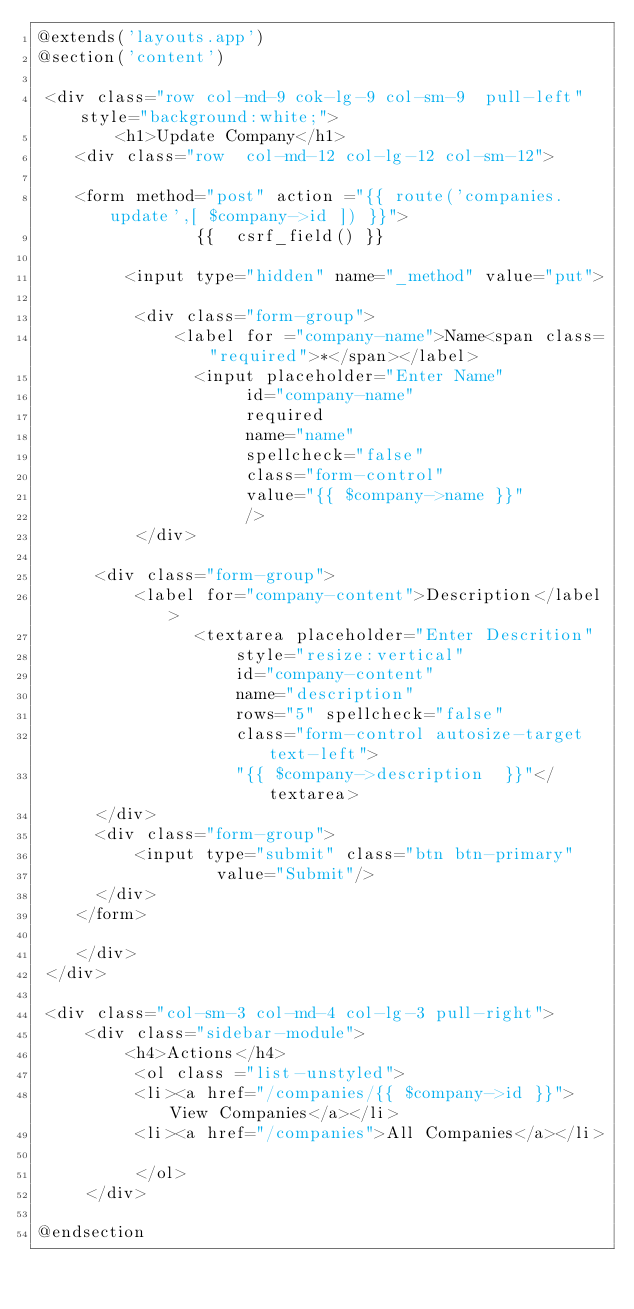Convert code to text. <code><loc_0><loc_0><loc_500><loc_500><_PHP_>@extends('layouts.app')
@section('content')

 <div class="row col-md-9 cok-lg-9 col-sm-9  pull-left" style="background:white;">
        <h1>Update Company</h1>
    <div class="row  col-md-12 col-lg-12 col-sm-12">

    <form method="post" action ="{{ route('companies.update',[ $company->id ]) }}">
                {{  csrf_field() }}

         <input type="hidden" name="_method" value="put">

          <div class="form-group">
              <label for ="company-name">Name<span class="required">*</span></label>
                <input placeholder="Enter Name"
                     id="company-name"
                     required
                     name="name"
                     spellcheck="false"
                     class="form-control"
                     value="{{ $company->name }}"
                     />
          </div>

      <div class="form-group">
          <label for="company-content">Description</label>
                <textarea placeholder="Enter Descrition"
                    style="resize:vertical"
                    id="company-content"
                    name="description"
                    rows="5" spellcheck="false"
                    class="form-control autosize-target text-left">
                    "{{ $company->description  }}"</textarea>
      </div>
      <div class="form-group">
          <input type="submit" class="btn btn-primary"
                  value="Submit"/>
      </div>
    </form>

    </div>
 </div>

 <div class="col-sm-3 col-md-4 col-lg-3 pull-right">
     <div class="sidebar-module">
         <h4>Actions</h4>
          <ol class ="list-unstyled">
          <li><a href="/companies/{{ $company->id }}">View Companies</a></li>
          <li><a href="/companies">All Companies</a></li>

          </ol>
     </div>

@endsection



</code> 